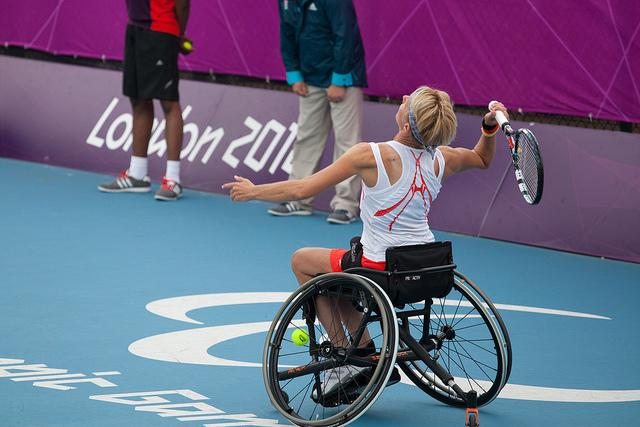In which class of the sport does the tennis player compete?

Choices:
A) college
B) amateur
C) juniors
D) wheelchair wheelchair 